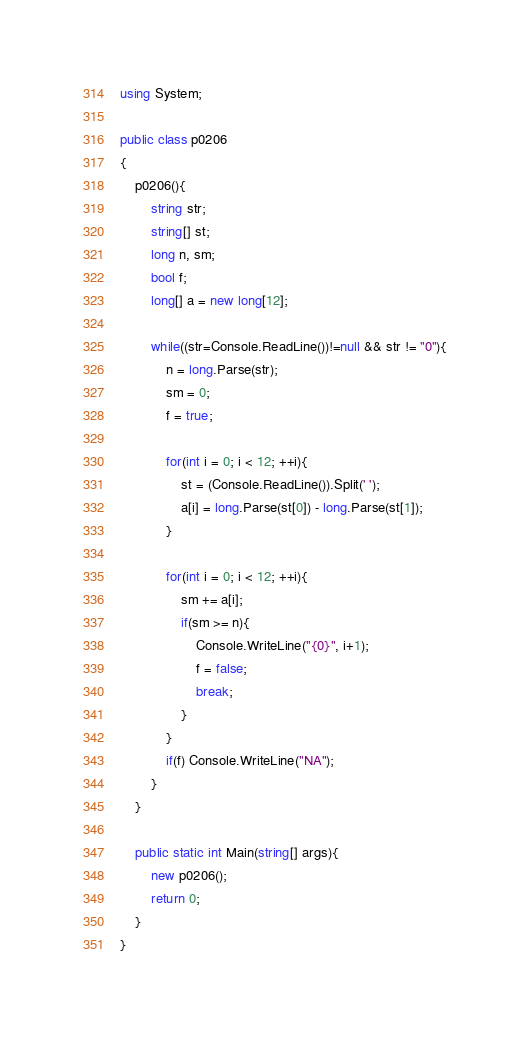<code> <loc_0><loc_0><loc_500><loc_500><_C#_>using System;

public class p0206
{
	p0206(){
		string str;
		string[] st;
		long n, sm;
		bool f;
		long[] a = new long[12];
		
		while((str=Console.ReadLine())!=null && str != "0"){
			n = long.Parse(str);
			sm = 0;
			f = true;
			
			for(int i = 0; i < 12; ++i){
				st = (Console.ReadLine()).Split(' ');
				a[i] = long.Parse(st[0]) - long.Parse(st[1]);
			}
			
			for(int i = 0; i < 12; ++i){
				sm += a[i];
				if(sm >= n){
					Console.WriteLine("{0}", i+1);
					f = false;
					break;
				}
			}
			if(f) Console.WriteLine("NA");
		}
	}
	
	public static int Main(string[] args){
		new p0206();
		return 0;
	}
}</code> 